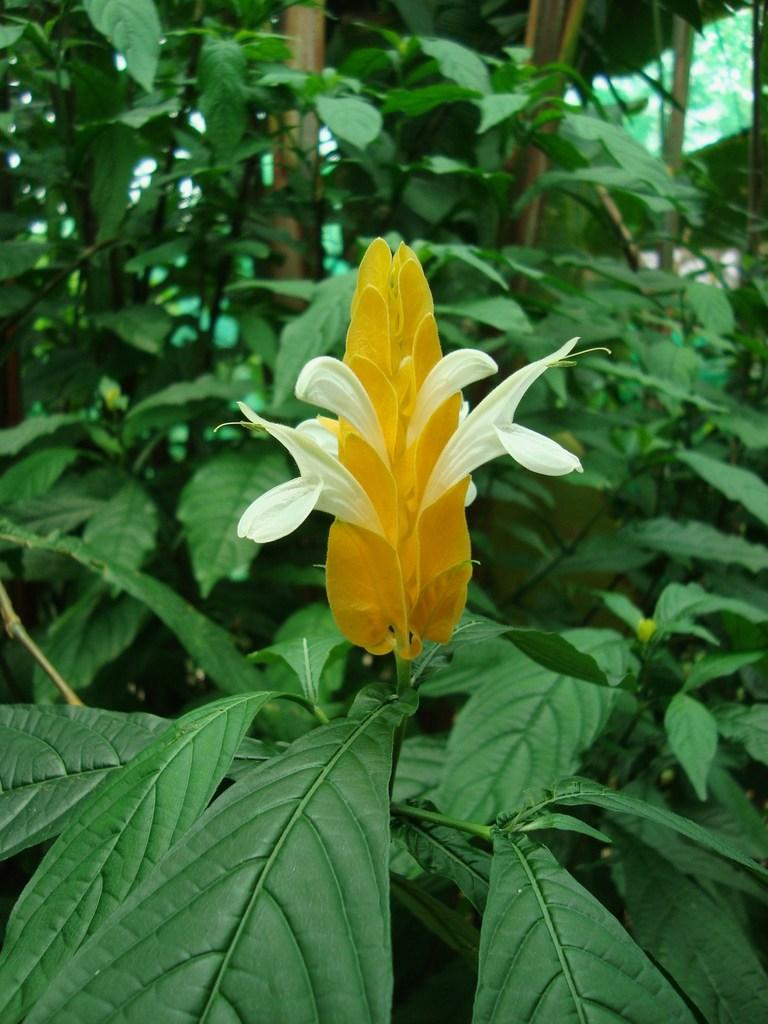What type of flower is on the plant in the image? There is a yellow flower on the plant in the image. What else can be seen at the base of the plant? There are leaves at the bottom of the plant. What can be seen in the background of the image? There is a shed and other plants visible in the background. What type of protest is happening in the image? There is no protest present in the image. --- Facts: 1. There is a person in the image. 2. The person is wearing a hat. 3. The person is holding a book. 4. The book has a red cover. 5. The person is sitting on a bench. Absurd Topics: elephant, piano Conversation: Who or what is in the image? There is a person in the image. What is the person wearing? The person is wearing a hat. What is the person holding? The person is holding a book. What can be said about the book? The book has a red cover. What is the person doing in the image? The person is sitting on a bench. Reasoning: Let's think step by step in order to produce the conversation. We start by identifying the main subject of the image, which is the person. Then, we describe specific details about the person, such as the hat and the book they are holding. Next, we provide information about the book, including its red cover. Finally, we describe the person's action in the image, which is sitting on a bench. Absurd Question/Answer: Can you hear the elephant playing the piano in the image? There is no elephant or piano present in the image. 